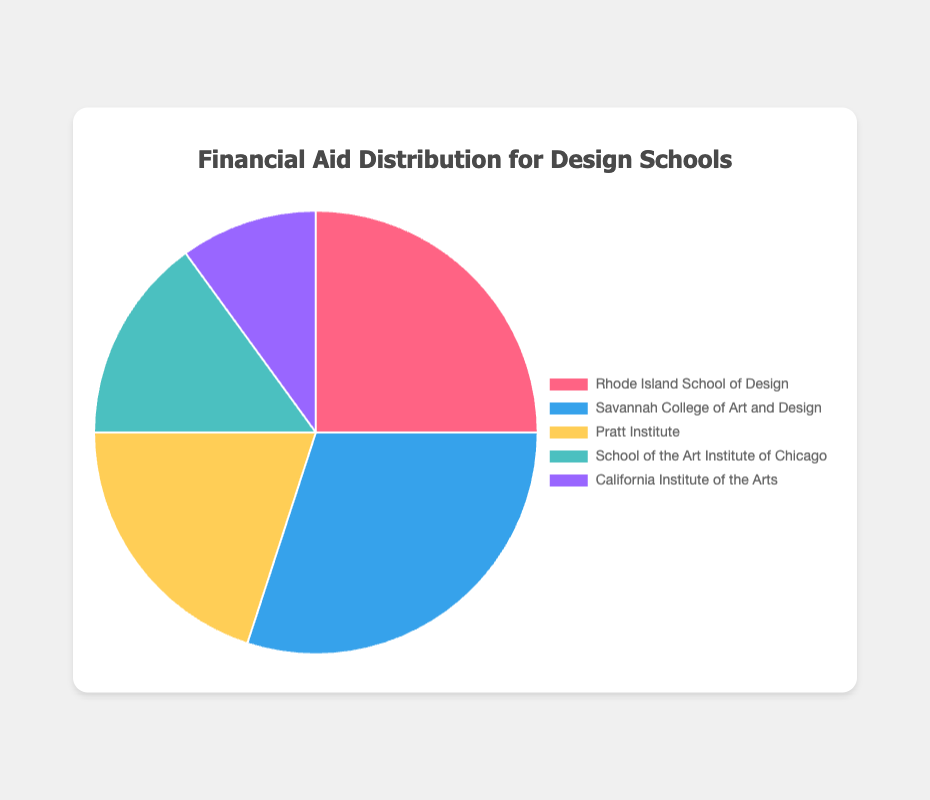Which design school has the highest percentage of financial aid distribution? By visual inspection of the pie chart, you can see that Savannah College of Art and Design has the largest segment. The chart shows that it occupies 30% of the financial aid distribution.
Answer: Savannah College of Art and Design What is the combined percentage of financial aid distribution for Rhode Island School of Design and Pratt Institute? To find the combined percentage, add the percentages of Rhode Island School of Design (25%) and Pratt Institute (20%). The computation is 25% + 20%.
Answer: 45% How much more financial aid is distributed to Savannah College of Art and Design compared to California Institute of the Arts? Subtract the percentage of financial aid distribution for California Institute of the Arts (10%) from that for Savannah College of Art and Design (30%). The computation is 30% - 10%.
Answer: 20% Which school has a lower percentage of financial aid distribution than Rhode Island School of Design but more than California Institute of the Arts? From the financial aid distribution values, Pratt Institute (20%) and School of the Art Institute of Chicago (15%) are both less than Rhode Island School of Design (25%). However, School of the Art Institute of Chicago (15%) is within the specified range.
Answer: School of the Art Institute of Chicago What is the average percentage of financial aid distribution across all the design schools? To find the average, sum all the given percentages and then divide by the number of schools. The sum is 25% + 30% + 20% + 15% + 10% = 100%. The number of schools is 5. Therefore, the average is 100% / 5.
Answer: 20% If the total financial aid budget is $1,000,000, how much is allocated to the School of the Art Institute of Chicago? First, identify the percentage share of the School of the Art Institute of Chicago, which is 15%. Then multiply this percentage by the total budget: 15% of $1,000,000 = 0.15 * $1,000,000.
Answer: $150,000 Which schools have a combined financial aid distribution percentage equal to that of Savannah College of Art and Design? Savannah College of Art and Design has a 30% share. Rhode Island School of Design and California Institute of the Arts together hold 25% + 10% = 35%, while Pratt Institute and School of the Art Institute of Chicago combined hold 20% + 15% = 35%. Thus none exactly match 30%, but individually they don't match equal combined distribution either. However, for exact pairs within the set, there's no match. For an exact answer of equal pairs: none.
Answer: none 